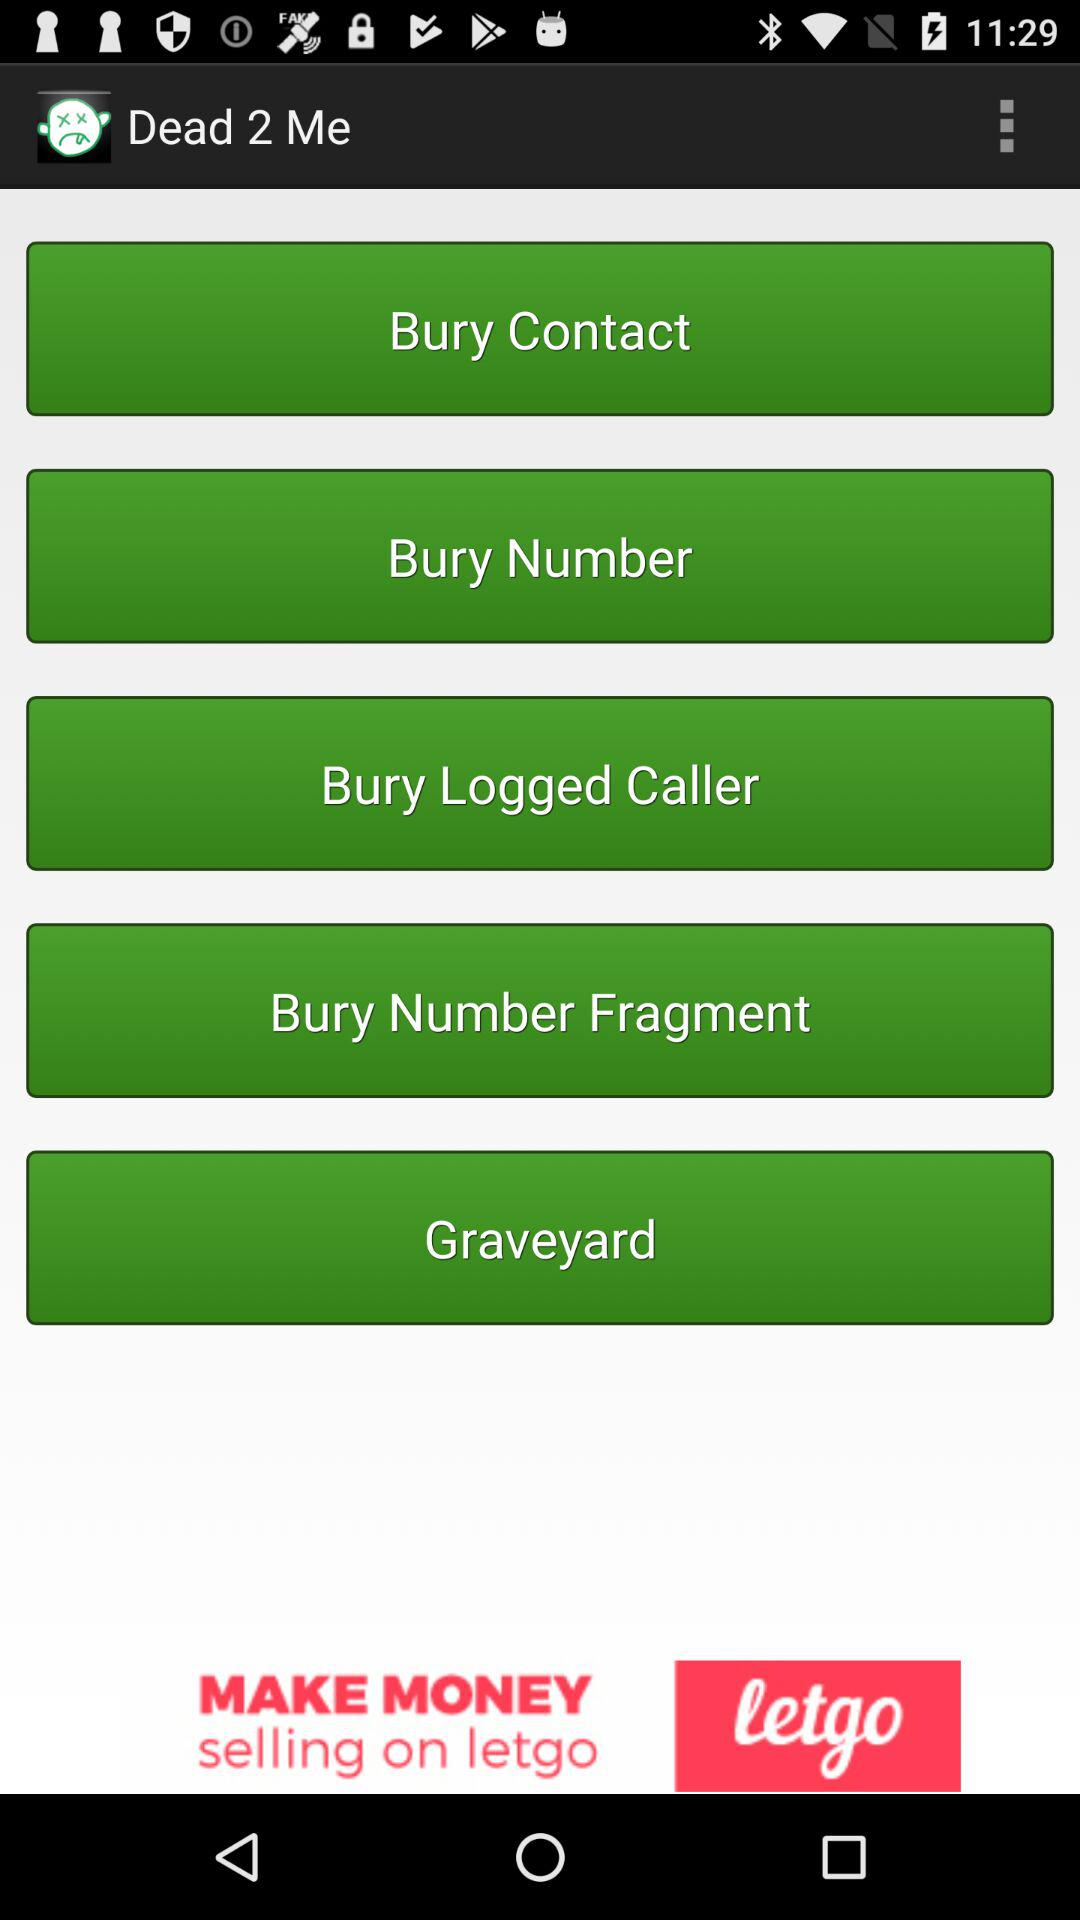What is the application name? The application name is "Dead 2 Me". 